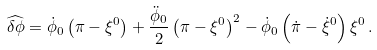Convert formula to latex. <formula><loc_0><loc_0><loc_500><loc_500>\widehat { \delta \phi } = \dot { \phi } _ { 0 } \left ( \pi - \xi ^ { 0 } \right ) + \frac { \ddot { \phi } _ { 0 } } { 2 } \left ( \pi - \xi ^ { 0 } \right ) ^ { 2 } - \dot { \phi } _ { 0 } \left ( \dot { \pi } - \dot { \xi } ^ { 0 } \right ) \xi ^ { 0 } \, .</formula> 